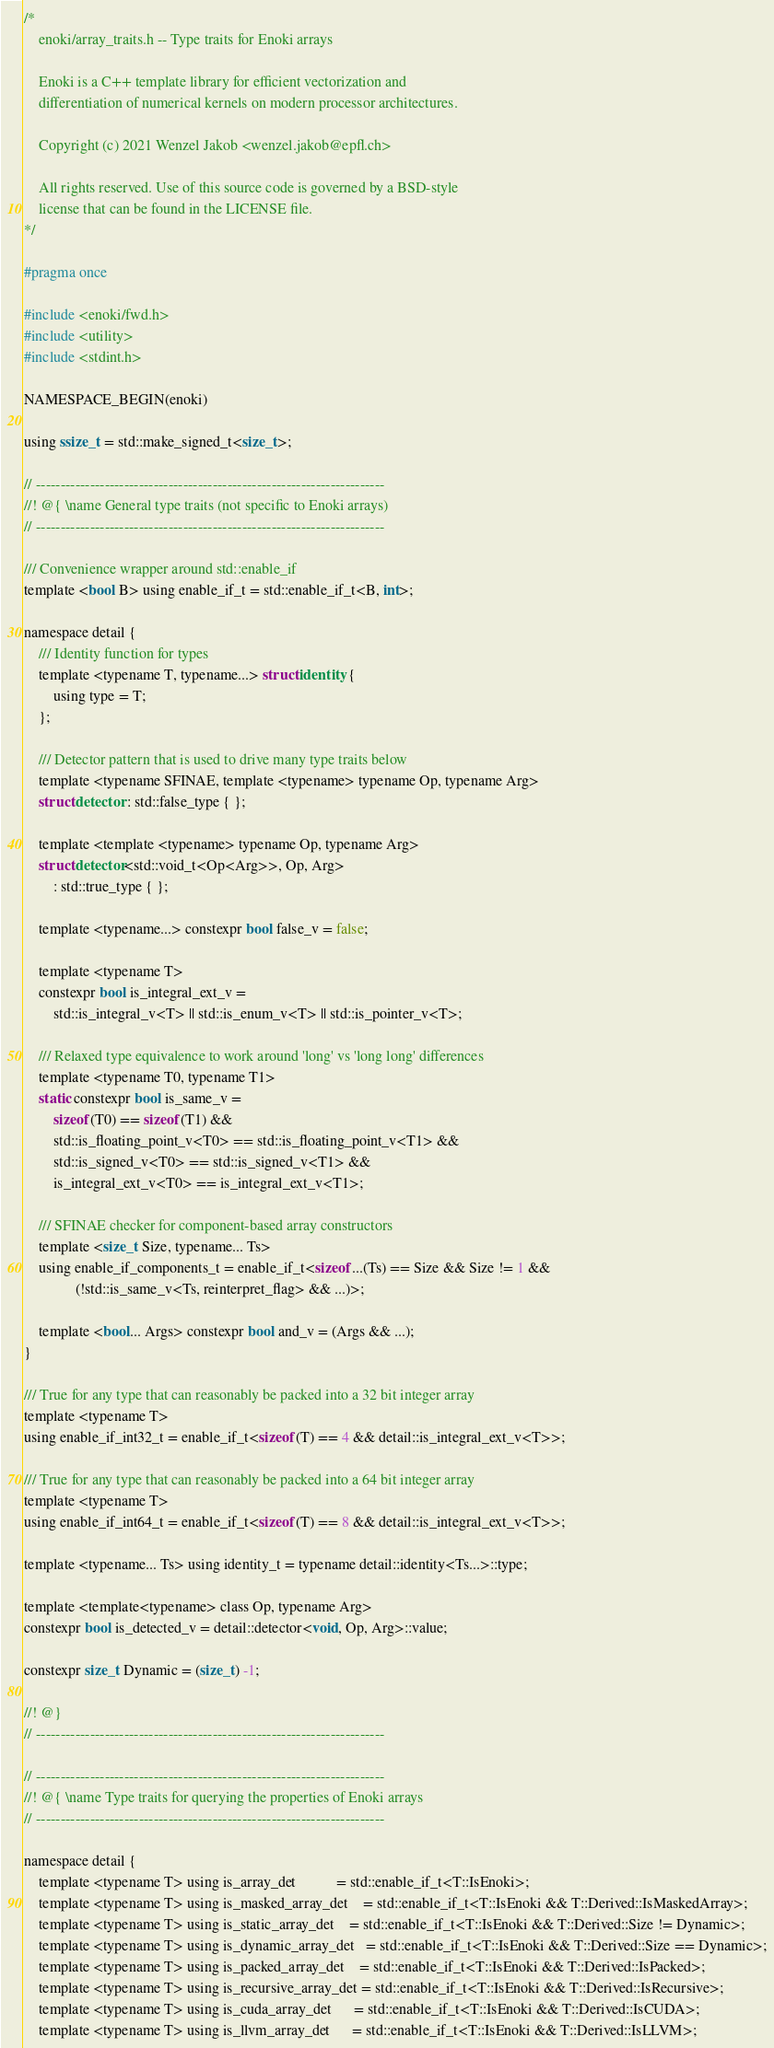<code> <loc_0><loc_0><loc_500><loc_500><_C_>/*
    enoki/array_traits.h -- Type traits for Enoki arrays

    Enoki is a C++ template library for efficient vectorization and
    differentiation of numerical kernels on modern processor architectures.

    Copyright (c) 2021 Wenzel Jakob <wenzel.jakob@epfl.ch>

    All rights reserved. Use of this source code is governed by a BSD-style
    license that can be found in the LICENSE file.
*/

#pragma once

#include <enoki/fwd.h>
#include <utility>
#include <stdint.h>

NAMESPACE_BEGIN(enoki)

using ssize_t = std::make_signed_t<size_t>;

// -----------------------------------------------------------------------
//! @{ \name General type traits (not specific to Enoki arrays)
// -----------------------------------------------------------------------

/// Convenience wrapper around std::enable_if
template <bool B> using enable_if_t = std::enable_if_t<B, int>;

namespace detail {
    /// Identity function for types
    template <typename T, typename...> struct identity {
        using type = T;
    };

    /// Detector pattern that is used to drive many type traits below
    template <typename SFINAE, template <typename> typename Op, typename Arg>
    struct detector : std::false_type { };

    template <template <typename> typename Op, typename Arg>
    struct detector<std::void_t<Op<Arg>>, Op, Arg>
        : std::true_type { };

    template <typename...> constexpr bool false_v = false;

    template <typename T>
    constexpr bool is_integral_ext_v =
        std::is_integral_v<T> || std::is_enum_v<T> || std::is_pointer_v<T>;

    /// Relaxed type equivalence to work around 'long' vs 'long long' differences
    template <typename T0, typename T1>
    static constexpr bool is_same_v =
        sizeof(T0) == sizeof(T1) &&
        std::is_floating_point_v<T0> == std::is_floating_point_v<T1> &&
        std::is_signed_v<T0> == std::is_signed_v<T1> &&
        is_integral_ext_v<T0> == is_integral_ext_v<T1>;

    /// SFINAE checker for component-based array constructors
    template <size_t Size, typename... Ts>
    using enable_if_components_t = enable_if_t<sizeof...(Ts) == Size && Size != 1 &&
              (!std::is_same_v<Ts, reinterpret_flag> && ...)>;

    template <bool... Args> constexpr bool and_v = (Args && ...);
}

/// True for any type that can reasonably be packed into a 32 bit integer array
template <typename T>
using enable_if_int32_t = enable_if_t<sizeof(T) == 4 && detail::is_integral_ext_v<T>>;

/// True for any type that can reasonably be packed into a 64 bit integer array
template <typename T>
using enable_if_int64_t = enable_if_t<sizeof(T) == 8 && detail::is_integral_ext_v<T>>;

template <typename... Ts> using identity_t = typename detail::identity<Ts...>::type;

template <template<typename> class Op, typename Arg>
constexpr bool is_detected_v = detail::detector<void, Op, Arg>::value;

constexpr size_t Dynamic = (size_t) -1;

//! @}
// -----------------------------------------------------------------------

// -----------------------------------------------------------------------
//! @{ \name Type traits for querying the properties of Enoki arrays
// -----------------------------------------------------------------------

namespace detail {
    template <typename T> using is_array_det           = std::enable_if_t<T::IsEnoki>;
    template <typename T> using is_masked_array_det    = std::enable_if_t<T::IsEnoki && T::Derived::IsMaskedArray>;
    template <typename T> using is_static_array_det    = std::enable_if_t<T::IsEnoki && T::Derived::Size != Dynamic>;
    template <typename T> using is_dynamic_array_det   = std::enable_if_t<T::IsEnoki && T::Derived::Size == Dynamic>;
    template <typename T> using is_packed_array_det    = std::enable_if_t<T::IsEnoki && T::Derived::IsPacked>;
    template <typename T> using is_recursive_array_det = std::enable_if_t<T::IsEnoki && T::Derived::IsRecursive>;
    template <typename T> using is_cuda_array_det      = std::enable_if_t<T::IsEnoki && T::Derived::IsCUDA>;
    template <typename T> using is_llvm_array_det      = std::enable_if_t<T::IsEnoki && T::Derived::IsLLVM>;</code> 